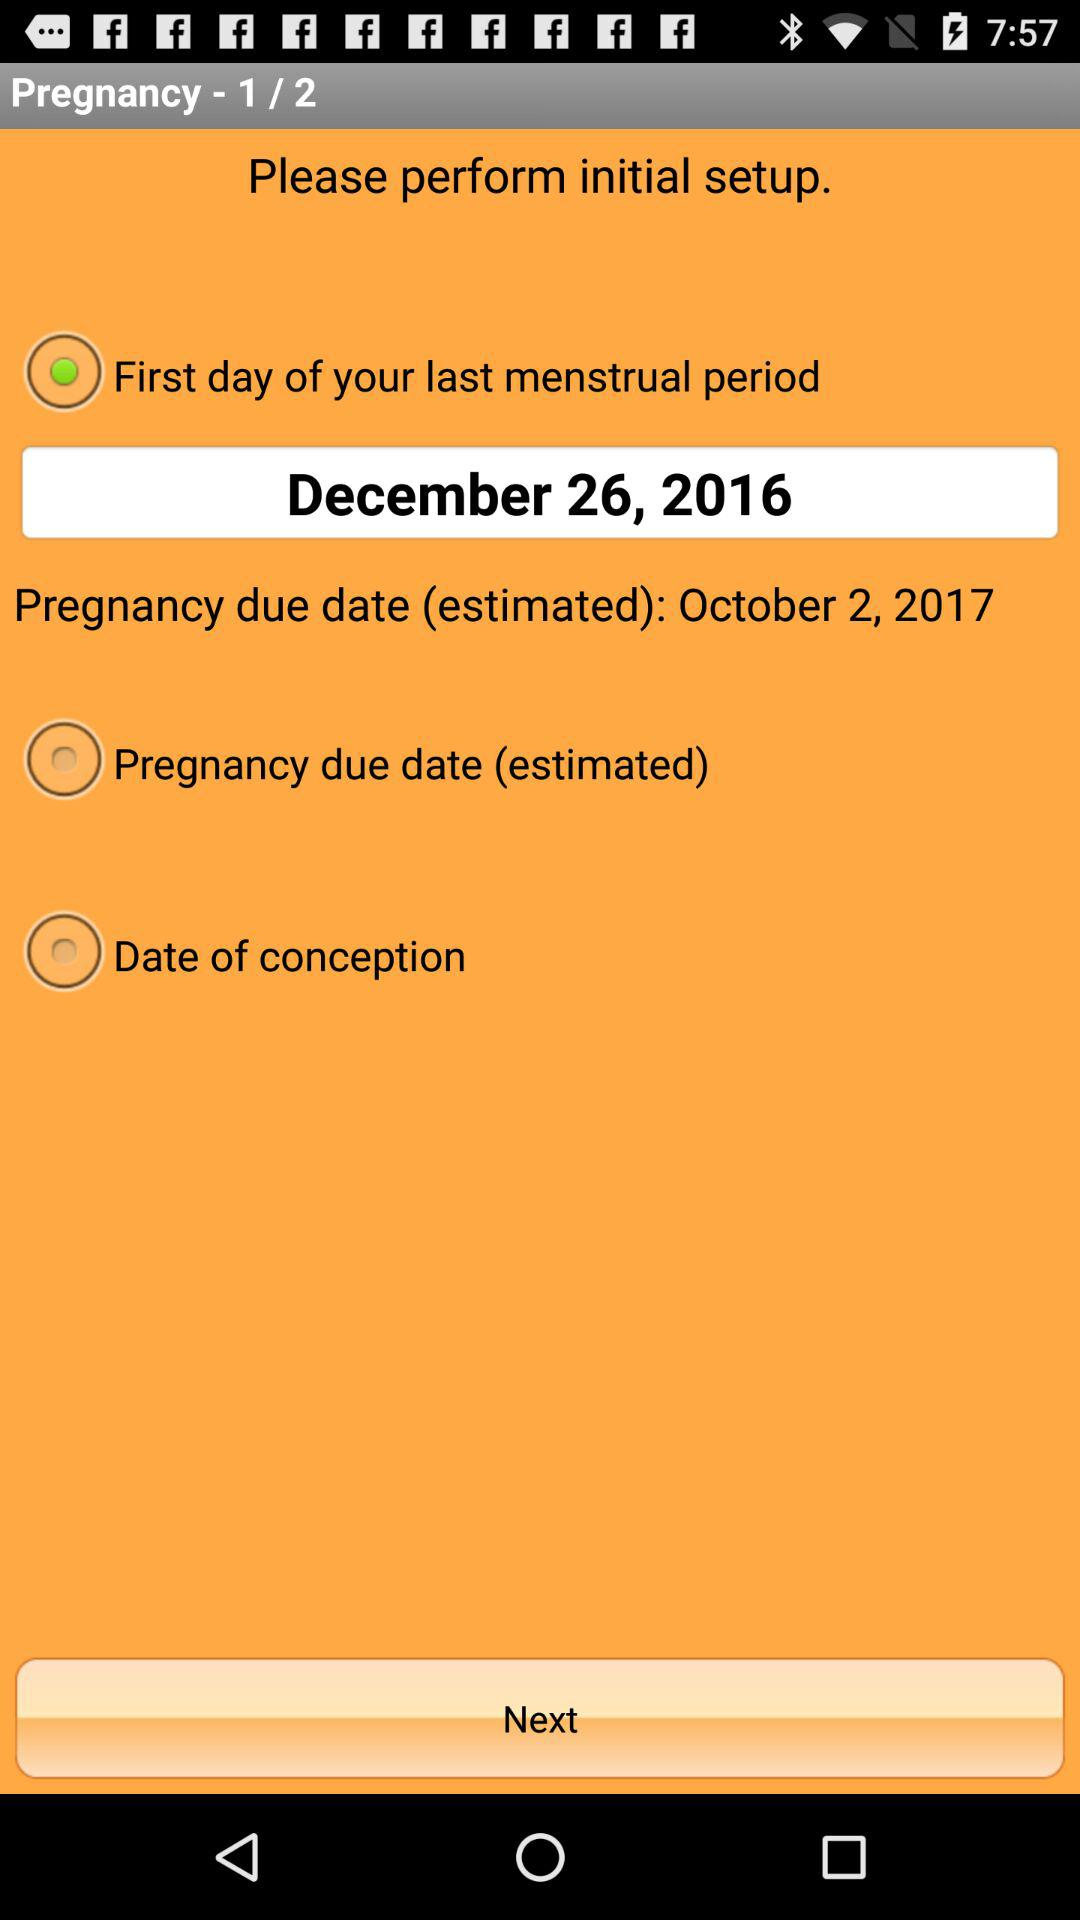How many steps in total are there? There are 2 steps in total. 